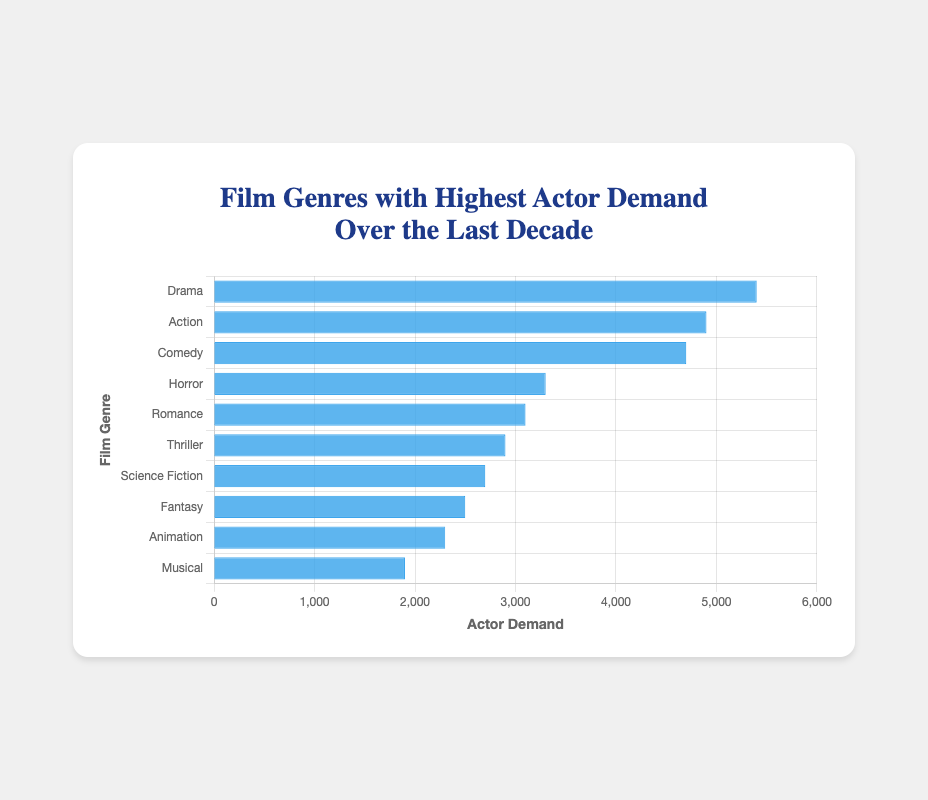Which genre has the highest actor demand? The genre with the highest bar represents the highest actor demand. Drama has the highest bar, indicating it has the highest demand.
Answer: Drama Which genre has the lowest actor demand? The genre with the shortest bar represents the lowest actor demand. Musical has the shortest bar, indicating it has the lowest demand.
Answer: Musical How much higher is the actor demand for Drama compared to Musical? Subtract the actor demand of Musical from that of Drama. Drama's demand is 5400 and Musical's is 1900. 5400 - 1900 = 3500.
Answer: 3500 What is the total actor demand for the top 3 genres? Sum the actor demands for Drama, Action, and Comedy. Drama (5400) + Action (4900) + Comedy (4700). 5400 + 4900 + 4700 = 15000.
Answer: 15000 Which genre has the closest actor demand to Science Fiction? Find the genre with actor demand closest to 2700. Thriller has a demand of 2900, which is closest to Science Fiction's 2700.
Answer: Thriller How many genres have an actor demand greater than 3000? Count the genres with bars higher than 3000 units on the x-axis. Drama, Action, Comedy, Horror, and Romance have demands greater than 3000. There are 5 such genres.
Answer: 5 Which genres have actor demands between Romance and Thriller? Identify the genres whose actor demands fall between Romance (3100) and Thriller (2900). Only Science Fiction falls within this range.
Answer: Science Fiction What is the difference in actor demand between the genres Action and Comedy? Subtract the actor demand of Comedy from that of Action. Action has 4900 and Comedy has 4700. 4900 - 4700 = 200.
Answer: 200 What is the average actor demand across all genres? Sum all actor demands and divide by the number of genres. (5400+4900+4700+3300+3100+2900+2700+2500+2300+1900) = 33700. 33700 / 10 = 3370.
Answer: 3370 Which genres have an actor demand of less than 2500? List the genres whose actor demands are less than 2500. Animation and Musical have demands of 2300 and 1900 respectively, which are less than 2500.
Answer: Animation, Musical 